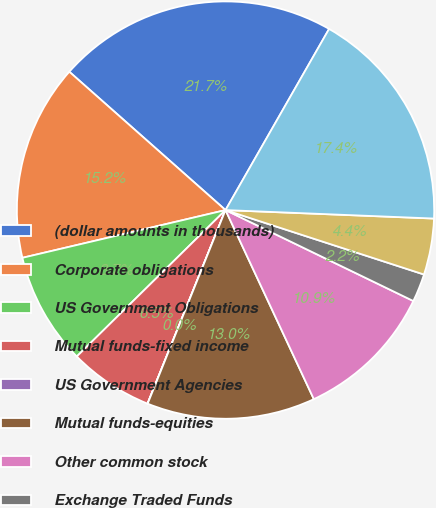Convert chart. <chart><loc_0><loc_0><loc_500><loc_500><pie_chart><fcel>(dollar amounts in thousands)<fcel>Corporate obligations<fcel>US Government Obligations<fcel>Mutual funds-fixed income<fcel>US Government Agencies<fcel>Mutual funds-equities<fcel>Other common stock<fcel>Exchange Traded Funds<fcel>Limited Partnerships<fcel>Fair value of plan assets<nl><fcel>21.73%<fcel>15.21%<fcel>8.7%<fcel>6.53%<fcel>0.01%<fcel>13.04%<fcel>10.87%<fcel>2.18%<fcel>4.35%<fcel>17.38%<nl></chart> 